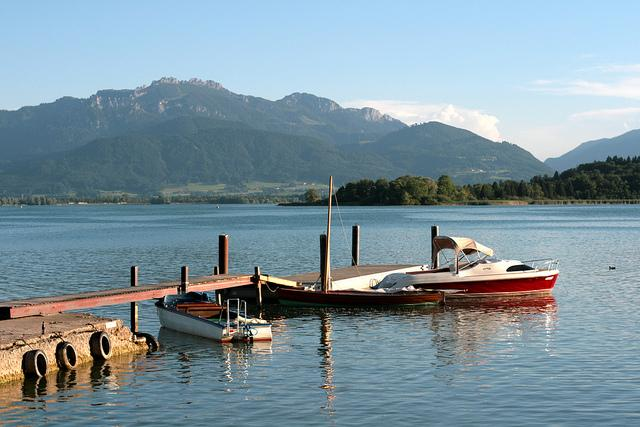What is the name of the platform used to walk out on the water?

Choices:
A) tub
B) plank
C) pier
D) steps pier 